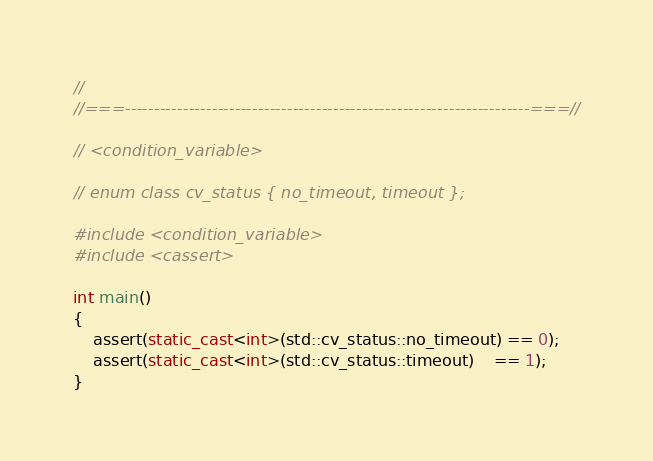<code> <loc_0><loc_0><loc_500><loc_500><_C++_>//
//===----------------------------------------------------------------------===//

// <condition_variable>

// enum class cv_status { no_timeout, timeout };

#include <condition_variable>
#include <cassert>

int main()
{
    assert(static_cast<int>(std::cv_status::no_timeout) == 0);
    assert(static_cast<int>(std::cv_status::timeout)    == 1);
}
</code> 